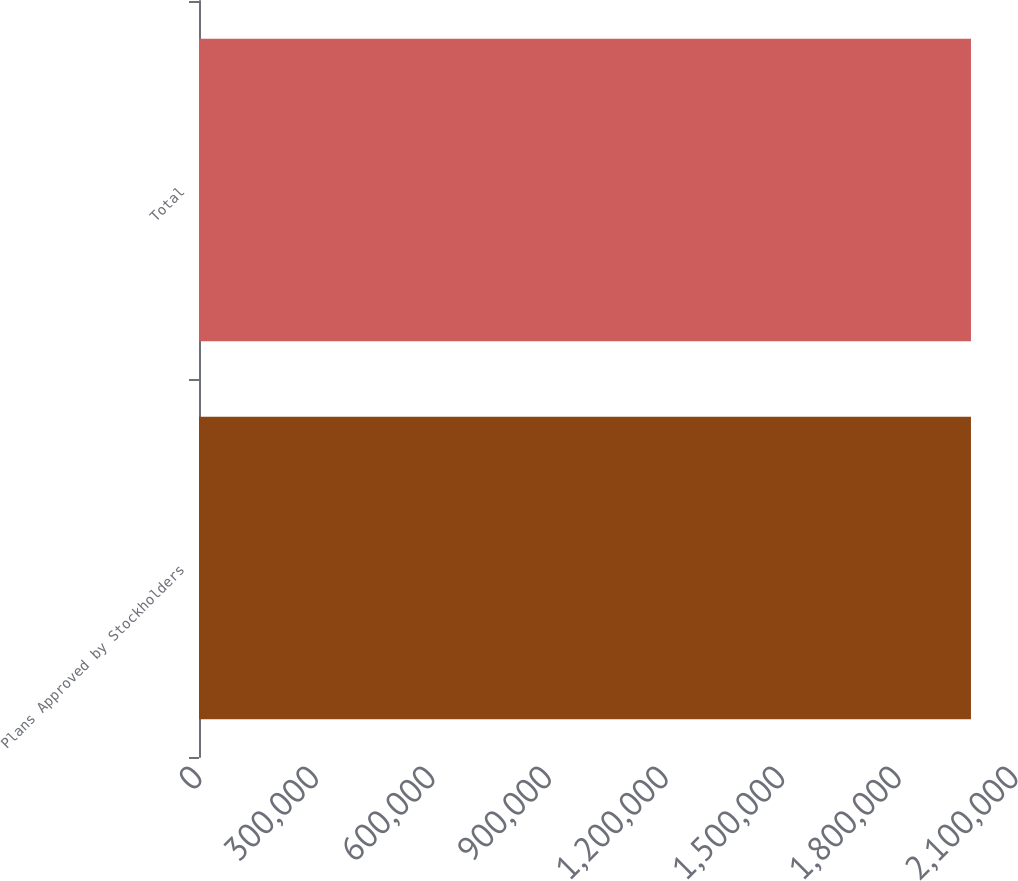Convert chart. <chart><loc_0><loc_0><loc_500><loc_500><bar_chart><fcel>Plans Approved by Stockholders<fcel>Total<nl><fcel>1.98668e+06<fcel>1.98668e+06<nl></chart> 